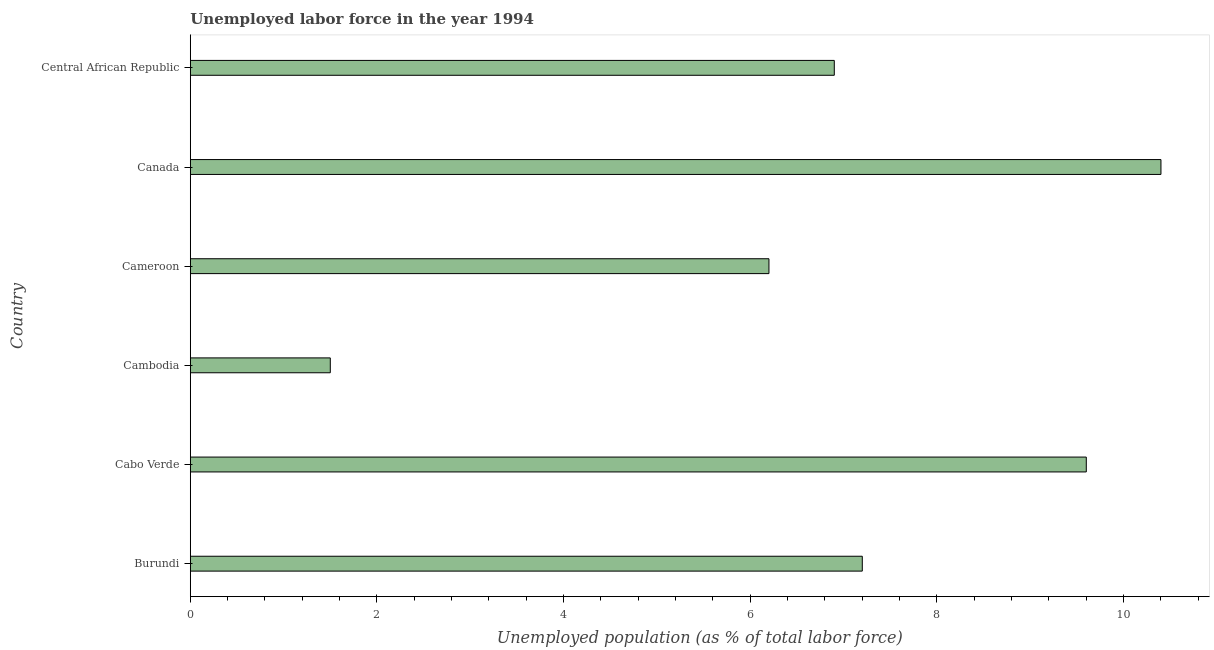What is the title of the graph?
Give a very brief answer. Unemployed labor force in the year 1994. What is the label or title of the X-axis?
Provide a succinct answer. Unemployed population (as % of total labor force). What is the total unemployed population in Cameroon?
Provide a short and direct response. 6.2. Across all countries, what is the maximum total unemployed population?
Ensure brevity in your answer.  10.4. In which country was the total unemployed population maximum?
Your answer should be very brief. Canada. In which country was the total unemployed population minimum?
Offer a terse response. Cambodia. What is the sum of the total unemployed population?
Offer a terse response. 41.8. What is the difference between the total unemployed population in Cambodia and Cameroon?
Make the answer very short. -4.7. What is the average total unemployed population per country?
Give a very brief answer. 6.97. What is the median total unemployed population?
Offer a terse response. 7.05. What is the ratio of the total unemployed population in Cabo Verde to that in Cameroon?
Ensure brevity in your answer.  1.55. Is the total unemployed population in Burundi less than that in Canada?
Offer a terse response. Yes. In how many countries, is the total unemployed population greater than the average total unemployed population taken over all countries?
Your answer should be very brief. 3. What is the difference between two consecutive major ticks on the X-axis?
Provide a short and direct response. 2. What is the Unemployed population (as % of total labor force) in Burundi?
Offer a very short reply. 7.2. What is the Unemployed population (as % of total labor force) of Cabo Verde?
Ensure brevity in your answer.  9.6. What is the Unemployed population (as % of total labor force) of Cambodia?
Ensure brevity in your answer.  1.5. What is the Unemployed population (as % of total labor force) in Cameroon?
Make the answer very short. 6.2. What is the Unemployed population (as % of total labor force) of Canada?
Offer a very short reply. 10.4. What is the Unemployed population (as % of total labor force) in Central African Republic?
Make the answer very short. 6.9. What is the difference between the Unemployed population (as % of total labor force) in Burundi and Cabo Verde?
Your response must be concise. -2.4. What is the difference between the Unemployed population (as % of total labor force) in Burundi and Cameroon?
Ensure brevity in your answer.  1. What is the difference between the Unemployed population (as % of total labor force) in Burundi and Central African Republic?
Provide a short and direct response. 0.3. What is the difference between the Unemployed population (as % of total labor force) in Cambodia and Canada?
Give a very brief answer. -8.9. What is the difference between the Unemployed population (as % of total labor force) in Cambodia and Central African Republic?
Provide a succinct answer. -5.4. What is the difference between the Unemployed population (as % of total labor force) in Cameroon and Central African Republic?
Give a very brief answer. -0.7. What is the ratio of the Unemployed population (as % of total labor force) in Burundi to that in Cabo Verde?
Your response must be concise. 0.75. What is the ratio of the Unemployed population (as % of total labor force) in Burundi to that in Cambodia?
Your answer should be very brief. 4.8. What is the ratio of the Unemployed population (as % of total labor force) in Burundi to that in Cameroon?
Offer a very short reply. 1.16. What is the ratio of the Unemployed population (as % of total labor force) in Burundi to that in Canada?
Offer a terse response. 0.69. What is the ratio of the Unemployed population (as % of total labor force) in Burundi to that in Central African Republic?
Your answer should be compact. 1.04. What is the ratio of the Unemployed population (as % of total labor force) in Cabo Verde to that in Cameroon?
Provide a succinct answer. 1.55. What is the ratio of the Unemployed population (as % of total labor force) in Cabo Verde to that in Canada?
Provide a short and direct response. 0.92. What is the ratio of the Unemployed population (as % of total labor force) in Cabo Verde to that in Central African Republic?
Keep it short and to the point. 1.39. What is the ratio of the Unemployed population (as % of total labor force) in Cambodia to that in Cameroon?
Provide a succinct answer. 0.24. What is the ratio of the Unemployed population (as % of total labor force) in Cambodia to that in Canada?
Ensure brevity in your answer.  0.14. What is the ratio of the Unemployed population (as % of total labor force) in Cambodia to that in Central African Republic?
Your answer should be very brief. 0.22. What is the ratio of the Unemployed population (as % of total labor force) in Cameroon to that in Canada?
Make the answer very short. 0.6. What is the ratio of the Unemployed population (as % of total labor force) in Cameroon to that in Central African Republic?
Make the answer very short. 0.9. What is the ratio of the Unemployed population (as % of total labor force) in Canada to that in Central African Republic?
Your response must be concise. 1.51. 